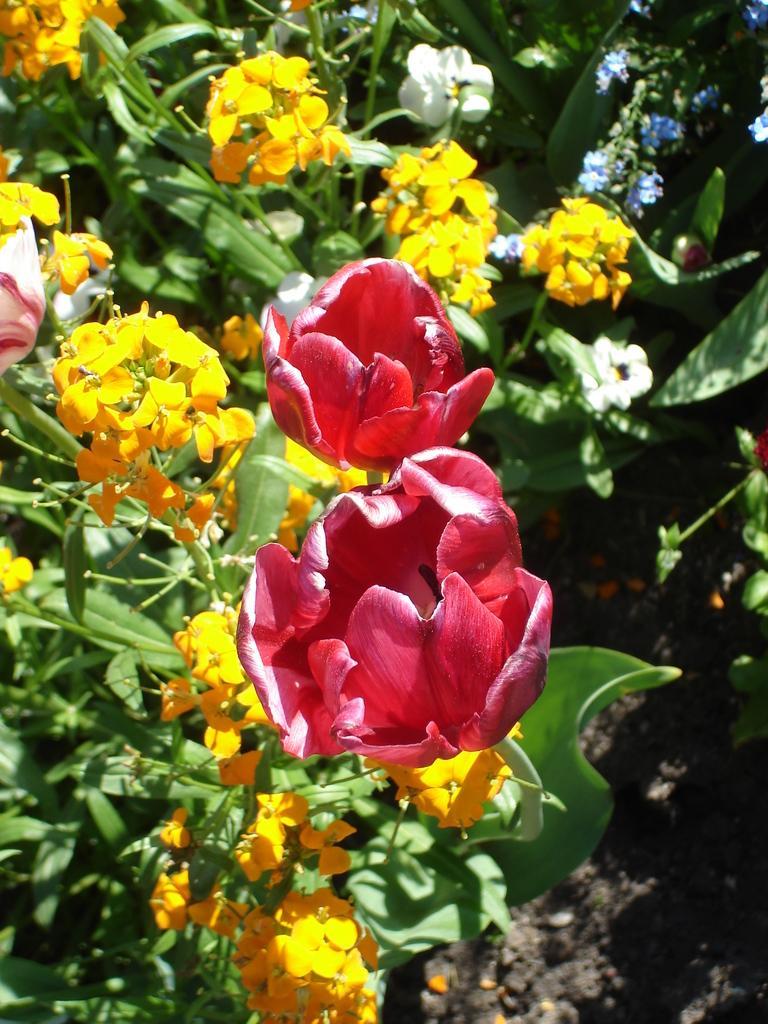In one or two sentences, can you explain what this image depicts? In this image there are few plants having flowers and leaves. Background there are few plants on the land. 